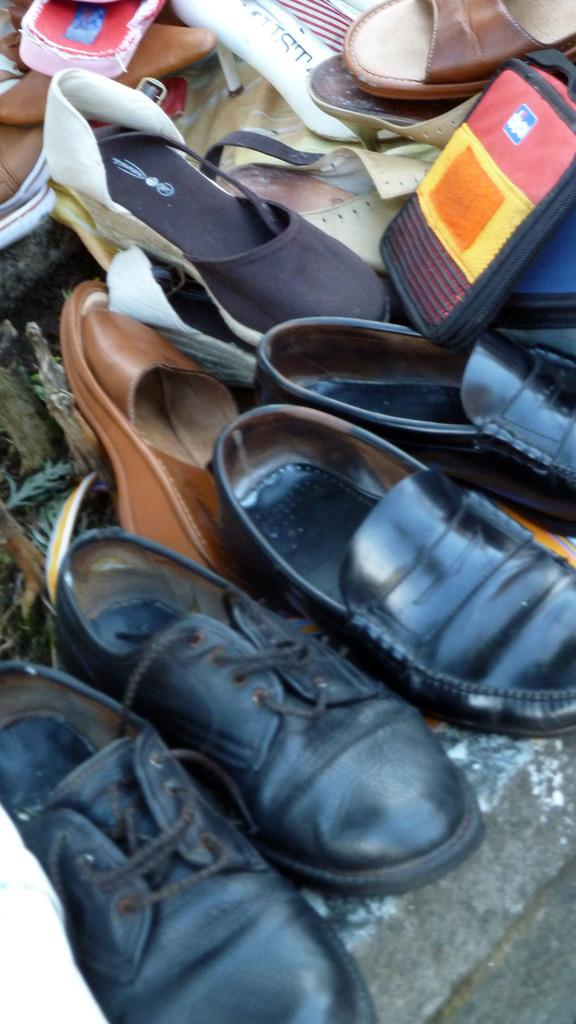What type of footwear can be seen in the image? There are a pair of shoes and sandals in the image. Where are the shoes and sandals located in the image? Both the shoes and sandals are placed on the floor. What type of joke is written on the letter in the image? There is no letter or joke present in the image; it only features a pair of shoes and sandals placed on the floor. 